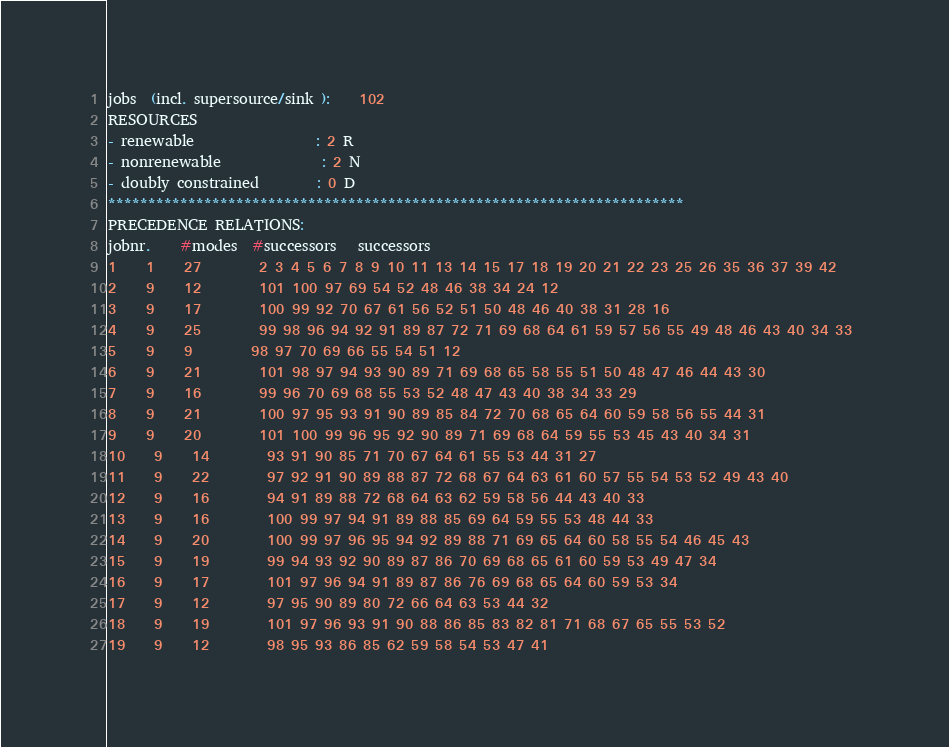<code> <loc_0><loc_0><loc_500><loc_500><_ObjectiveC_>jobs  (incl. supersource/sink ):	102
RESOURCES
- renewable                 : 2 R
- nonrenewable              : 2 N
- doubly constrained        : 0 D
************************************************************************
PRECEDENCE RELATIONS:
jobnr.    #modes  #successors   successors
1	1	27		2 3 4 5 6 7 8 9 10 11 13 14 15 17 18 19 20 21 22 23 25 26 35 36 37 39 42 
2	9	12		101 100 97 69 54 52 48 46 38 34 24 12 
3	9	17		100 99 92 70 67 61 56 52 51 50 48 46 40 38 31 28 16 
4	9	25		99 98 96 94 92 91 89 87 72 71 69 68 64 61 59 57 56 55 49 48 46 43 40 34 33 
5	9	9		98 97 70 69 66 55 54 51 12 
6	9	21		101 98 97 94 93 90 89 71 69 68 65 58 55 51 50 48 47 46 44 43 30 
7	9	16		99 96 70 69 68 55 53 52 48 47 43 40 38 34 33 29 
8	9	21		100 97 95 93 91 90 89 85 84 72 70 68 65 64 60 59 58 56 55 44 31 
9	9	20		101 100 99 96 95 92 90 89 71 69 68 64 59 55 53 45 43 40 34 31 
10	9	14		93 91 90 85 71 70 67 64 61 55 53 44 31 27 
11	9	22		97 92 91 90 89 88 87 72 68 67 64 63 61 60 57 55 54 53 52 49 43 40 
12	9	16		94 91 89 88 72 68 64 63 62 59 58 56 44 43 40 33 
13	9	16		100 99 97 94 91 89 88 85 69 64 59 55 53 48 44 33 
14	9	20		100 99 97 96 95 94 92 89 88 71 69 65 64 60 58 55 54 46 45 43 
15	9	19		99 94 93 92 90 89 87 86 70 69 68 65 61 60 59 53 49 47 34 
16	9	17		101 97 96 94 91 89 87 86 76 69 68 65 64 60 59 53 34 
17	9	12		97 95 90 89 80 72 66 64 63 53 44 32 
18	9	19		101 97 96 93 91 90 88 86 85 83 82 81 71 68 67 65 55 53 52 
19	9	12		98 95 93 86 85 62 59 58 54 53 47 41 </code> 